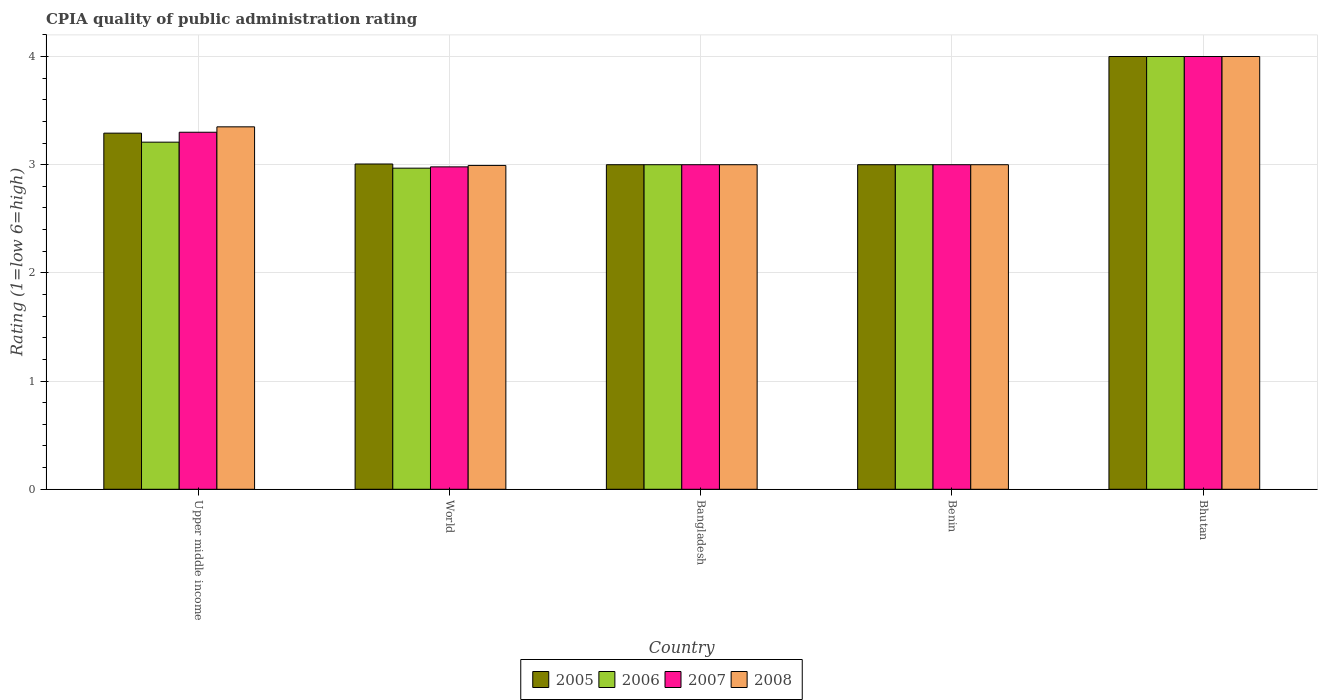How many bars are there on the 2nd tick from the right?
Offer a very short reply. 4. What is the label of the 4th group of bars from the left?
Your answer should be compact. Benin. In how many cases, is the number of bars for a given country not equal to the number of legend labels?
Your response must be concise. 0. Across all countries, what is the maximum CPIA rating in 2007?
Your answer should be compact. 4. Across all countries, what is the minimum CPIA rating in 2008?
Keep it short and to the point. 2.99. In which country was the CPIA rating in 2008 maximum?
Provide a short and direct response. Bhutan. In which country was the CPIA rating in 2005 minimum?
Your answer should be very brief. Bangladesh. What is the total CPIA rating in 2007 in the graph?
Offer a terse response. 16.28. What is the difference between the CPIA rating in 2008 in Upper middle income and that in World?
Your answer should be compact. 0.36. What is the difference between the CPIA rating in 2005 in Benin and the CPIA rating in 2006 in Bhutan?
Offer a terse response. -1. What is the average CPIA rating in 2005 per country?
Ensure brevity in your answer.  3.26. What is the difference between the CPIA rating of/in 2007 and CPIA rating of/in 2005 in World?
Your answer should be very brief. -0.03. What is the ratio of the CPIA rating in 2008 in Bangladesh to that in Bhutan?
Offer a terse response. 0.75. Is the difference between the CPIA rating in 2007 in Bhutan and World greater than the difference between the CPIA rating in 2005 in Bhutan and World?
Give a very brief answer. Yes. What is the difference between the highest and the second highest CPIA rating in 2005?
Your response must be concise. -0.29. Is the sum of the CPIA rating in 2008 in Benin and Bhutan greater than the maximum CPIA rating in 2007 across all countries?
Give a very brief answer. Yes. Is it the case that in every country, the sum of the CPIA rating in 2005 and CPIA rating in 2007 is greater than the CPIA rating in 2008?
Give a very brief answer. Yes. How many bars are there?
Provide a succinct answer. 20. Are all the bars in the graph horizontal?
Make the answer very short. No. What is the difference between two consecutive major ticks on the Y-axis?
Your answer should be very brief. 1. Are the values on the major ticks of Y-axis written in scientific E-notation?
Give a very brief answer. No. Does the graph contain any zero values?
Offer a very short reply. No. Where does the legend appear in the graph?
Offer a terse response. Bottom center. How many legend labels are there?
Offer a very short reply. 4. What is the title of the graph?
Keep it short and to the point. CPIA quality of public administration rating. What is the label or title of the X-axis?
Ensure brevity in your answer.  Country. What is the label or title of the Y-axis?
Give a very brief answer. Rating (1=low 6=high). What is the Rating (1=low 6=high) in 2005 in Upper middle income?
Provide a succinct answer. 3.29. What is the Rating (1=low 6=high) in 2006 in Upper middle income?
Keep it short and to the point. 3.21. What is the Rating (1=low 6=high) of 2007 in Upper middle income?
Keep it short and to the point. 3.3. What is the Rating (1=low 6=high) in 2008 in Upper middle income?
Keep it short and to the point. 3.35. What is the Rating (1=low 6=high) in 2005 in World?
Your answer should be compact. 3.01. What is the Rating (1=low 6=high) of 2006 in World?
Give a very brief answer. 2.97. What is the Rating (1=low 6=high) in 2007 in World?
Keep it short and to the point. 2.98. What is the Rating (1=low 6=high) in 2008 in World?
Your answer should be very brief. 2.99. What is the Rating (1=low 6=high) of 2005 in Bangladesh?
Provide a short and direct response. 3. What is the Rating (1=low 6=high) in 2006 in Bangladesh?
Offer a terse response. 3. What is the Rating (1=low 6=high) in 2007 in Bangladesh?
Provide a succinct answer. 3. What is the Rating (1=low 6=high) in 2005 in Benin?
Provide a short and direct response. 3. What is the Rating (1=low 6=high) of 2006 in Benin?
Offer a terse response. 3. What is the Rating (1=low 6=high) in 2006 in Bhutan?
Your answer should be very brief. 4. Across all countries, what is the maximum Rating (1=low 6=high) of 2005?
Keep it short and to the point. 4. Across all countries, what is the maximum Rating (1=low 6=high) in 2008?
Keep it short and to the point. 4. Across all countries, what is the minimum Rating (1=low 6=high) in 2005?
Your response must be concise. 3. Across all countries, what is the minimum Rating (1=low 6=high) in 2006?
Your answer should be very brief. 2.97. Across all countries, what is the minimum Rating (1=low 6=high) of 2007?
Give a very brief answer. 2.98. Across all countries, what is the minimum Rating (1=low 6=high) of 2008?
Make the answer very short. 2.99. What is the total Rating (1=low 6=high) of 2005 in the graph?
Offer a terse response. 16.3. What is the total Rating (1=low 6=high) in 2006 in the graph?
Provide a short and direct response. 16.18. What is the total Rating (1=low 6=high) in 2007 in the graph?
Give a very brief answer. 16.28. What is the total Rating (1=low 6=high) of 2008 in the graph?
Your response must be concise. 16.34. What is the difference between the Rating (1=low 6=high) in 2005 in Upper middle income and that in World?
Provide a succinct answer. 0.29. What is the difference between the Rating (1=low 6=high) of 2006 in Upper middle income and that in World?
Make the answer very short. 0.24. What is the difference between the Rating (1=low 6=high) of 2007 in Upper middle income and that in World?
Offer a very short reply. 0.32. What is the difference between the Rating (1=low 6=high) of 2008 in Upper middle income and that in World?
Make the answer very short. 0.36. What is the difference between the Rating (1=low 6=high) in 2005 in Upper middle income and that in Bangladesh?
Your answer should be very brief. 0.29. What is the difference between the Rating (1=low 6=high) in 2006 in Upper middle income and that in Bangladesh?
Provide a succinct answer. 0.21. What is the difference between the Rating (1=low 6=high) in 2008 in Upper middle income and that in Bangladesh?
Offer a terse response. 0.35. What is the difference between the Rating (1=low 6=high) of 2005 in Upper middle income and that in Benin?
Your answer should be very brief. 0.29. What is the difference between the Rating (1=low 6=high) in 2006 in Upper middle income and that in Benin?
Give a very brief answer. 0.21. What is the difference between the Rating (1=low 6=high) of 2007 in Upper middle income and that in Benin?
Keep it short and to the point. 0.3. What is the difference between the Rating (1=low 6=high) of 2008 in Upper middle income and that in Benin?
Offer a very short reply. 0.35. What is the difference between the Rating (1=low 6=high) in 2005 in Upper middle income and that in Bhutan?
Give a very brief answer. -0.71. What is the difference between the Rating (1=low 6=high) in 2006 in Upper middle income and that in Bhutan?
Make the answer very short. -0.79. What is the difference between the Rating (1=low 6=high) in 2007 in Upper middle income and that in Bhutan?
Offer a terse response. -0.7. What is the difference between the Rating (1=low 6=high) of 2008 in Upper middle income and that in Bhutan?
Make the answer very short. -0.65. What is the difference between the Rating (1=low 6=high) of 2005 in World and that in Bangladesh?
Your answer should be compact. 0.01. What is the difference between the Rating (1=low 6=high) of 2006 in World and that in Bangladesh?
Make the answer very short. -0.03. What is the difference between the Rating (1=low 6=high) of 2007 in World and that in Bangladesh?
Provide a short and direct response. -0.02. What is the difference between the Rating (1=low 6=high) of 2008 in World and that in Bangladesh?
Offer a very short reply. -0.01. What is the difference between the Rating (1=low 6=high) of 2005 in World and that in Benin?
Offer a very short reply. 0.01. What is the difference between the Rating (1=low 6=high) in 2006 in World and that in Benin?
Keep it short and to the point. -0.03. What is the difference between the Rating (1=low 6=high) of 2007 in World and that in Benin?
Provide a short and direct response. -0.02. What is the difference between the Rating (1=low 6=high) of 2008 in World and that in Benin?
Offer a very short reply. -0.01. What is the difference between the Rating (1=low 6=high) of 2005 in World and that in Bhutan?
Offer a very short reply. -0.99. What is the difference between the Rating (1=low 6=high) in 2006 in World and that in Bhutan?
Offer a terse response. -1.03. What is the difference between the Rating (1=low 6=high) in 2007 in World and that in Bhutan?
Offer a very short reply. -1.02. What is the difference between the Rating (1=low 6=high) of 2008 in World and that in Bhutan?
Provide a succinct answer. -1.01. What is the difference between the Rating (1=low 6=high) of 2007 in Bangladesh and that in Benin?
Your answer should be very brief. 0. What is the difference between the Rating (1=low 6=high) of 2006 in Bangladesh and that in Bhutan?
Make the answer very short. -1. What is the difference between the Rating (1=low 6=high) of 2006 in Benin and that in Bhutan?
Provide a succinct answer. -1. What is the difference between the Rating (1=low 6=high) in 2007 in Benin and that in Bhutan?
Your answer should be compact. -1. What is the difference between the Rating (1=low 6=high) of 2005 in Upper middle income and the Rating (1=low 6=high) of 2006 in World?
Make the answer very short. 0.32. What is the difference between the Rating (1=low 6=high) in 2005 in Upper middle income and the Rating (1=low 6=high) in 2007 in World?
Your response must be concise. 0.31. What is the difference between the Rating (1=low 6=high) in 2005 in Upper middle income and the Rating (1=low 6=high) in 2008 in World?
Make the answer very short. 0.3. What is the difference between the Rating (1=low 6=high) of 2006 in Upper middle income and the Rating (1=low 6=high) of 2007 in World?
Provide a short and direct response. 0.23. What is the difference between the Rating (1=low 6=high) in 2006 in Upper middle income and the Rating (1=low 6=high) in 2008 in World?
Make the answer very short. 0.21. What is the difference between the Rating (1=low 6=high) in 2007 in Upper middle income and the Rating (1=low 6=high) in 2008 in World?
Your answer should be very brief. 0.31. What is the difference between the Rating (1=low 6=high) of 2005 in Upper middle income and the Rating (1=low 6=high) of 2006 in Bangladesh?
Ensure brevity in your answer.  0.29. What is the difference between the Rating (1=low 6=high) in 2005 in Upper middle income and the Rating (1=low 6=high) in 2007 in Bangladesh?
Your response must be concise. 0.29. What is the difference between the Rating (1=low 6=high) in 2005 in Upper middle income and the Rating (1=low 6=high) in 2008 in Bangladesh?
Your answer should be very brief. 0.29. What is the difference between the Rating (1=low 6=high) of 2006 in Upper middle income and the Rating (1=low 6=high) of 2007 in Bangladesh?
Offer a terse response. 0.21. What is the difference between the Rating (1=low 6=high) in 2006 in Upper middle income and the Rating (1=low 6=high) in 2008 in Bangladesh?
Your answer should be compact. 0.21. What is the difference between the Rating (1=low 6=high) of 2005 in Upper middle income and the Rating (1=low 6=high) of 2006 in Benin?
Your answer should be very brief. 0.29. What is the difference between the Rating (1=low 6=high) in 2005 in Upper middle income and the Rating (1=low 6=high) in 2007 in Benin?
Ensure brevity in your answer.  0.29. What is the difference between the Rating (1=low 6=high) of 2005 in Upper middle income and the Rating (1=low 6=high) of 2008 in Benin?
Your response must be concise. 0.29. What is the difference between the Rating (1=low 6=high) of 2006 in Upper middle income and the Rating (1=low 6=high) of 2007 in Benin?
Your answer should be very brief. 0.21. What is the difference between the Rating (1=low 6=high) of 2006 in Upper middle income and the Rating (1=low 6=high) of 2008 in Benin?
Offer a very short reply. 0.21. What is the difference between the Rating (1=low 6=high) of 2005 in Upper middle income and the Rating (1=low 6=high) of 2006 in Bhutan?
Your answer should be compact. -0.71. What is the difference between the Rating (1=low 6=high) in 2005 in Upper middle income and the Rating (1=low 6=high) in 2007 in Bhutan?
Offer a terse response. -0.71. What is the difference between the Rating (1=low 6=high) in 2005 in Upper middle income and the Rating (1=low 6=high) in 2008 in Bhutan?
Offer a very short reply. -0.71. What is the difference between the Rating (1=low 6=high) in 2006 in Upper middle income and the Rating (1=low 6=high) in 2007 in Bhutan?
Keep it short and to the point. -0.79. What is the difference between the Rating (1=low 6=high) of 2006 in Upper middle income and the Rating (1=low 6=high) of 2008 in Bhutan?
Make the answer very short. -0.79. What is the difference between the Rating (1=low 6=high) of 2007 in Upper middle income and the Rating (1=low 6=high) of 2008 in Bhutan?
Keep it short and to the point. -0.7. What is the difference between the Rating (1=low 6=high) of 2005 in World and the Rating (1=low 6=high) of 2006 in Bangladesh?
Provide a succinct answer. 0.01. What is the difference between the Rating (1=low 6=high) of 2005 in World and the Rating (1=low 6=high) of 2007 in Bangladesh?
Give a very brief answer. 0.01. What is the difference between the Rating (1=low 6=high) in 2005 in World and the Rating (1=low 6=high) in 2008 in Bangladesh?
Your response must be concise. 0.01. What is the difference between the Rating (1=low 6=high) in 2006 in World and the Rating (1=low 6=high) in 2007 in Bangladesh?
Offer a terse response. -0.03. What is the difference between the Rating (1=low 6=high) in 2006 in World and the Rating (1=low 6=high) in 2008 in Bangladesh?
Provide a succinct answer. -0.03. What is the difference between the Rating (1=low 6=high) in 2007 in World and the Rating (1=low 6=high) in 2008 in Bangladesh?
Keep it short and to the point. -0.02. What is the difference between the Rating (1=low 6=high) in 2005 in World and the Rating (1=low 6=high) in 2006 in Benin?
Provide a short and direct response. 0.01. What is the difference between the Rating (1=low 6=high) in 2005 in World and the Rating (1=low 6=high) in 2007 in Benin?
Your answer should be compact. 0.01. What is the difference between the Rating (1=low 6=high) in 2005 in World and the Rating (1=low 6=high) in 2008 in Benin?
Ensure brevity in your answer.  0.01. What is the difference between the Rating (1=low 6=high) in 2006 in World and the Rating (1=low 6=high) in 2007 in Benin?
Offer a terse response. -0.03. What is the difference between the Rating (1=low 6=high) in 2006 in World and the Rating (1=low 6=high) in 2008 in Benin?
Ensure brevity in your answer.  -0.03. What is the difference between the Rating (1=low 6=high) in 2007 in World and the Rating (1=low 6=high) in 2008 in Benin?
Make the answer very short. -0.02. What is the difference between the Rating (1=low 6=high) of 2005 in World and the Rating (1=low 6=high) of 2006 in Bhutan?
Keep it short and to the point. -0.99. What is the difference between the Rating (1=low 6=high) in 2005 in World and the Rating (1=low 6=high) in 2007 in Bhutan?
Your answer should be compact. -0.99. What is the difference between the Rating (1=low 6=high) in 2005 in World and the Rating (1=low 6=high) in 2008 in Bhutan?
Keep it short and to the point. -0.99. What is the difference between the Rating (1=low 6=high) of 2006 in World and the Rating (1=low 6=high) of 2007 in Bhutan?
Make the answer very short. -1.03. What is the difference between the Rating (1=low 6=high) in 2006 in World and the Rating (1=low 6=high) in 2008 in Bhutan?
Provide a succinct answer. -1.03. What is the difference between the Rating (1=low 6=high) in 2007 in World and the Rating (1=low 6=high) in 2008 in Bhutan?
Your response must be concise. -1.02. What is the difference between the Rating (1=low 6=high) in 2005 in Bangladesh and the Rating (1=low 6=high) in 2007 in Benin?
Make the answer very short. 0. What is the difference between the Rating (1=low 6=high) in 2005 in Bangladesh and the Rating (1=low 6=high) in 2008 in Benin?
Offer a very short reply. 0. What is the difference between the Rating (1=low 6=high) in 2006 in Bangladesh and the Rating (1=low 6=high) in 2008 in Benin?
Ensure brevity in your answer.  0. What is the difference between the Rating (1=low 6=high) in 2005 in Bangladesh and the Rating (1=low 6=high) in 2007 in Bhutan?
Give a very brief answer. -1. What is the difference between the Rating (1=low 6=high) of 2006 in Bangladesh and the Rating (1=low 6=high) of 2007 in Bhutan?
Ensure brevity in your answer.  -1. What is the difference between the Rating (1=low 6=high) of 2007 in Bangladesh and the Rating (1=low 6=high) of 2008 in Bhutan?
Provide a succinct answer. -1. What is the difference between the Rating (1=low 6=high) in 2005 in Benin and the Rating (1=low 6=high) in 2007 in Bhutan?
Ensure brevity in your answer.  -1. What is the difference between the Rating (1=low 6=high) in 2006 in Benin and the Rating (1=low 6=high) in 2008 in Bhutan?
Offer a terse response. -1. What is the difference between the Rating (1=low 6=high) of 2007 in Benin and the Rating (1=low 6=high) of 2008 in Bhutan?
Your answer should be very brief. -1. What is the average Rating (1=low 6=high) of 2005 per country?
Your answer should be compact. 3.26. What is the average Rating (1=low 6=high) in 2006 per country?
Your answer should be very brief. 3.24. What is the average Rating (1=low 6=high) in 2007 per country?
Give a very brief answer. 3.26. What is the average Rating (1=low 6=high) of 2008 per country?
Your answer should be compact. 3.27. What is the difference between the Rating (1=low 6=high) of 2005 and Rating (1=low 6=high) of 2006 in Upper middle income?
Provide a short and direct response. 0.08. What is the difference between the Rating (1=low 6=high) in 2005 and Rating (1=low 6=high) in 2007 in Upper middle income?
Offer a very short reply. -0.01. What is the difference between the Rating (1=low 6=high) of 2005 and Rating (1=low 6=high) of 2008 in Upper middle income?
Offer a very short reply. -0.06. What is the difference between the Rating (1=low 6=high) in 2006 and Rating (1=low 6=high) in 2007 in Upper middle income?
Offer a terse response. -0.09. What is the difference between the Rating (1=low 6=high) in 2006 and Rating (1=low 6=high) in 2008 in Upper middle income?
Offer a very short reply. -0.14. What is the difference between the Rating (1=low 6=high) of 2005 and Rating (1=low 6=high) of 2006 in World?
Make the answer very short. 0.04. What is the difference between the Rating (1=low 6=high) in 2005 and Rating (1=low 6=high) in 2007 in World?
Offer a terse response. 0.03. What is the difference between the Rating (1=low 6=high) in 2005 and Rating (1=low 6=high) in 2008 in World?
Your response must be concise. 0.01. What is the difference between the Rating (1=low 6=high) of 2006 and Rating (1=low 6=high) of 2007 in World?
Offer a very short reply. -0.01. What is the difference between the Rating (1=low 6=high) of 2006 and Rating (1=low 6=high) of 2008 in World?
Keep it short and to the point. -0.03. What is the difference between the Rating (1=low 6=high) of 2007 and Rating (1=low 6=high) of 2008 in World?
Provide a short and direct response. -0.01. What is the difference between the Rating (1=low 6=high) of 2005 and Rating (1=low 6=high) of 2007 in Bangladesh?
Your answer should be very brief. 0. What is the difference between the Rating (1=low 6=high) in 2005 and Rating (1=low 6=high) in 2008 in Bangladesh?
Give a very brief answer. 0. What is the difference between the Rating (1=low 6=high) of 2006 and Rating (1=low 6=high) of 2007 in Bangladesh?
Make the answer very short. 0. What is the difference between the Rating (1=low 6=high) in 2005 and Rating (1=low 6=high) in 2007 in Benin?
Keep it short and to the point. 0. What is the difference between the Rating (1=low 6=high) of 2006 and Rating (1=low 6=high) of 2007 in Benin?
Ensure brevity in your answer.  0. What is the difference between the Rating (1=low 6=high) in 2006 and Rating (1=low 6=high) in 2008 in Benin?
Your answer should be compact. 0. What is the difference between the Rating (1=low 6=high) of 2005 and Rating (1=low 6=high) of 2008 in Bhutan?
Provide a short and direct response. 0. What is the difference between the Rating (1=low 6=high) in 2006 and Rating (1=low 6=high) in 2007 in Bhutan?
Provide a succinct answer. 0. What is the difference between the Rating (1=low 6=high) of 2006 and Rating (1=low 6=high) of 2008 in Bhutan?
Keep it short and to the point. 0. What is the difference between the Rating (1=low 6=high) in 2007 and Rating (1=low 6=high) in 2008 in Bhutan?
Your answer should be very brief. 0. What is the ratio of the Rating (1=low 6=high) of 2005 in Upper middle income to that in World?
Give a very brief answer. 1.09. What is the ratio of the Rating (1=low 6=high) in 2006 in Upper middle income to that in World?
Provide a succinct answer. 1.08. What is the ratio of the Rating (1=low 6=high) of 2007 in Upper middle income to that in World?
Keep it short and to the point. 1.11. What is the ratio of the Rating (1=low 6=high) in 2008 in Upper middle income to that in World?
Your response must be concise. 1.12. What is the ratio of the Rating (1=low 6=high) of 2005 in Upper middle income to that in Bangladesh?
Give a very brief answer. 1.1. What is the ratio of the Rating (1=low 6=high) of 2006 in Upper middle income to that in Bangladesh?
Provide a short and direct response. 1.07. What is the ratio of the Rating (1=low 6=high) in 2007 in Upper middle income to that in Bangladesh?
Your answer should be compact. 1.1. What is the ratio of the Rating (1=low 6=high) in 2008 in Upper middle income to that in Bangladesh?
Give a very brief answer. 1.12. What is the ratio of the Rating (1=low 6=high) in 2005 in Upper middle income to that in Benin?
Offer a terse response. 1.1. What is the ratio of the Rating (1=low 6=high) in 2006 in Upper middle income to that in Benin?
Ensure brevity in your answer.  1.07. What is the ratio of the Rating (1=low 6=high) of 2007 in Upper middle income to that in Benin?
Your response must be concise. 1.1. What is the ratio of the Rating (1=low 6=high) of 2008 in Upper middle income to that in Benin?
Give a very brief answer. 1.12. What is the ratio of the Rating (1=low 6=high) of 2005 in Upper middle income to that in Bhutan?
Provide a succinct answer. 0.82. What is the ratio of the Rating (1=low 6=high) of 2006 in Upper middle income to that in Bhutan?
Give a very brief answer. 0.8. What is the ratio of the Rating (1=low 6=high) of 2007 in Upper middle income to that in Bhutan?
Ensure brevity in your answer.  0.82. What is the ratio of the Rating (1=low 6=high) in 2008 in Upper middle income to that in Bhutan?
Your response must be concise. 0.84. What is the ratio of the Rating (1=low 6=high) in 2005 in World to that in Bangladesh?
Provide a succinct answer. 1. What is the ratio of the Rating (1=low 6=high) of 2006 in World to that in Bangladesh?
Ensure brevity in your answer.  0.99. What is the ratio of the Rating (1=low 6=high) of 2005 in World to that in Benin?
Your answer should be compact. 1. What is the ratio of the Rating (1=low 6=high) in 2006 in World to that in Benin?
Provide a succinct answer. 0.99. What is the ratio of the Rating (1=low 6=high) in 2007 in World to that in Benin?
Your response must be concise. 0.99. What is the ratio of the Rating (1=low 6=high) of 2005 in World to that in Bhutan?
Keep it short and to the point. 0.75. What is the ratio of the Rating (1=low 6=high) of 2006 in World to that in Bhutan?
Offer a terse response. 0.74. What is the ratio of the Rating (1=low 6=high) in 2007 in World to that in Bhutan?
Make the answer very short. 0.74. What is the ratio of the Rating (1=low 6=high) of 2008 in World to that in Bhutan?
Offer a terse response. 0.75. What is the ratio of the Rating (1=low 6=high) of 2005 in Bangladesh to that in Benin?
Ensure brevity in your answer.  1. What is the ratio of the Rating (1=low 6=high) of 2006 in Bangladesh to that in Benin?
Your answer should be compact. 1. What is the ratio of the Rating (1=low 6=high) in 2007 in Bangladesh to that in Benin?
Provide a succinct answer. 1. What is the ratio of the Rating (1=low 6=high) of 2005 in Bangladesh to that in Bhutan?
Ensure brevity in your answer.  0.75. What is the ratio of the Rating (1=low 6=high) of 2006 in Bangladesh to that in Bhutan?
Your answer should be compact. 0.75. What is the ratio of the Rating (1=low 6=high) in 2007 in Bangladesh to that in Bhutan?
Ensure brevity in your answer.  0.75. What is the ratio of the Rating (1=low 6=high) in 2007 in Benin to that in Bhutan?
Offer a terse response. 0.75. What is the difference between the highest and the second highest Rating (1=low 6=high) of 2005?
Provide a succinct answer. 0.71. What is the difference between the highest and the second highest Rating (1=low 6=high) in 2006?
Offer a very short reply. 0.79. What is the difference between the highest and the second highest Rating (1=low 6=high) in 2008?
Provide a short and direct response. 0.65. What is the difference between the highest and the lowest Rating (1=low 6=high) in 2006?
Ensure brevity in your answer.  1.03. What is the difference between the highest and the lowest Rating (1=low 6=high) of 2007?
Your response must be concise. 1.02. What is the difference between the highest and the lowest Rating (1=low 6=high) in 2008?
Provide a succinct answer. 1.01. 